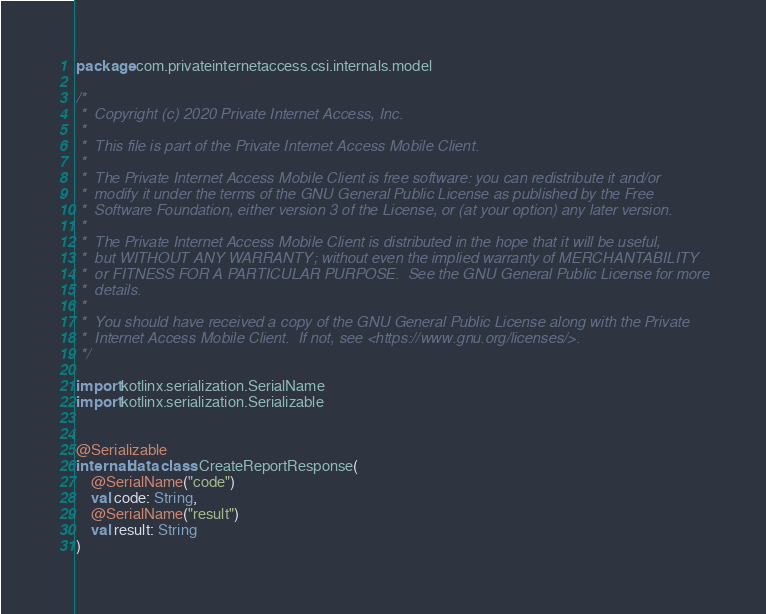Convert code to text. <code><loc_0><loc_0><loc_500><loc_500><_Kotlin_>package com.privateinternetaccess.csi.internals.model

/*
 *  Copyright (c) 2020 Private Internet Access, Inc.
 *
 *  This file is part of the Private Internet Access Mobile Client.
 *
 *  The Private Internet Access Mobile Client is free software: you can redistribute it and/or
 *  modify it under the terms of the GNU General Public License as published by the Free
 *  Software Foundation, either version 3 of the License, or (at your option) any later version.
 *
 *  The Private Internet Access Mobile Client is distributed in the hope that it will be useful,
 *  but WITHOUT ANY WARRANTY; without even the implied warranty of MERCHANTABILITY
 *  or FITNESS FOR A PARTICULAR PURPOSE.  See the GNU General Public License for more
 *  details.
 *
 *  You should have received a copy of the GNU General Public License along with the Private
 *  Internet Access Mobile Client.  If not, see <https://www.gnu.org/licenses/>.
 */

import kotlinx.serialization.SerialName
import kotlinx.serialization.Serializable


@Serializable
internal data class CreateReportResponse(
    @SerialName("code")
    val code: String,
    @SerialName("result")
    val result: String
)</code> 